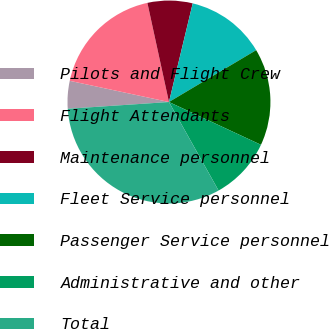Convert chart to OTSL. <chart><loc_0><loc_0><loc_500><loc_500><pie_chart><fcel>Pilots and Flight Crew<fcel>Flight Attendants<fcel>Maintenance personnel<fcel>Fleet Service personnel<fcel>Passenger Service personnel<fcel>Administrative and other<fcel>Total<nl><fcel>4.41%<fcel>18.24%<fcel>7.17%<fcel>12.7%<fcel>15.47%<fcel>9.94%<fcel>32.07%<nl></chart> 